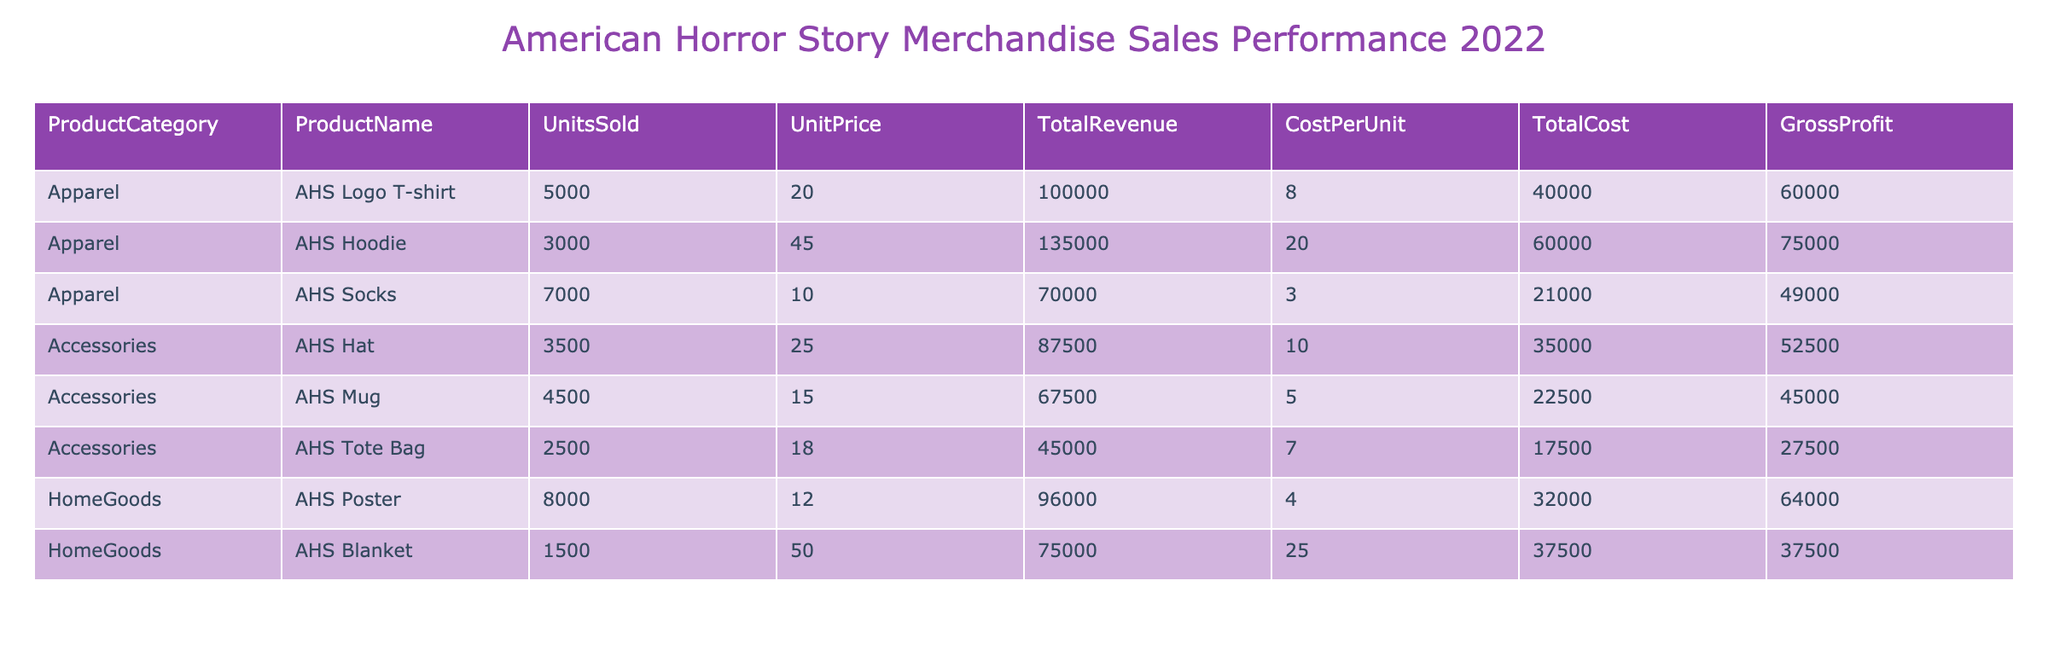What is the total revenue generated from AHS Hoodies? The total revenue from AHS Hoodies can be found under the Total Revenue column for that product category. Looking at the table, it shows a Total Revenue of 135000 for AHS Hoodies.
Answer: 135000 What product category had the highest total cost? To find the product category with the highest total cost, I will compare the Total Cost values for each category. The total costs listed are: Apparel (60000 + 40000 + 21000 = 121000), Accessories (35000 + 22500 + 17500 = 75000), HomeGoods (32000 + 37500 = 69500). Apparel has the highest total cost of 121000.
Answer: Apparel How much gross profit was made from AHS Socks? The gross profit for AHS Socks is provided in the Gross Profit column for that product. Looking at the table, AHS Socks show a Gross Profit of 49000.
Answer: 49000 What is the average unit price of all merchandise sold? To calculate the average unit price, I will sum all unit prices (20 + 45 + 10 + 25 + 15 + 18 + 12 + 50) = 205 and divide by the number of products, which is 8. Thus, the average unit price is 205 / 8 = 25.625.
Answer: 25.625 Did the total revenue from HomeGoods exceed the total revenue from Accessories? First, I will calculate the total revenue for HomeGoods (96000 + 75000 = 171000) and the total revenue for Accessories (87500 + 67500 + 45000 = 200000). Since 171000 is less than 200000, the statement is false.
Answer: No Which product had the highest gross profit margin? To find the product with the highest gross profit margin, I will calculate the gross profit margin for each product by using (Gross Profit / Total Revenue) * 100. For example, for AHS Logo T-shirt, it is (60000 / 100000) * 100 = 60%, and similarly for others. After calculating, AHS Hoodie has the highest margin at (75000 / 135000) * 100 = 55.56%. Thus, AHS Logo T-shirt has the highest margin at 60%.
Answer: AHS Logo T-shirt What was the total number of units sold across all merchandise? To find the total units sold, I will add the Units Sold for all products: 5000 + 3000 + 7000 + 3500 + 4500 + 2500 + 8000 + 1500 = 30000.
Answer: 30000 Is the total revenue from AHS Mugs more than 50000? The total revenue from AHS Mugs is shown in the table as 67500. Since 67500 is greater than 50000, the statement is true.
Answer: Yes 